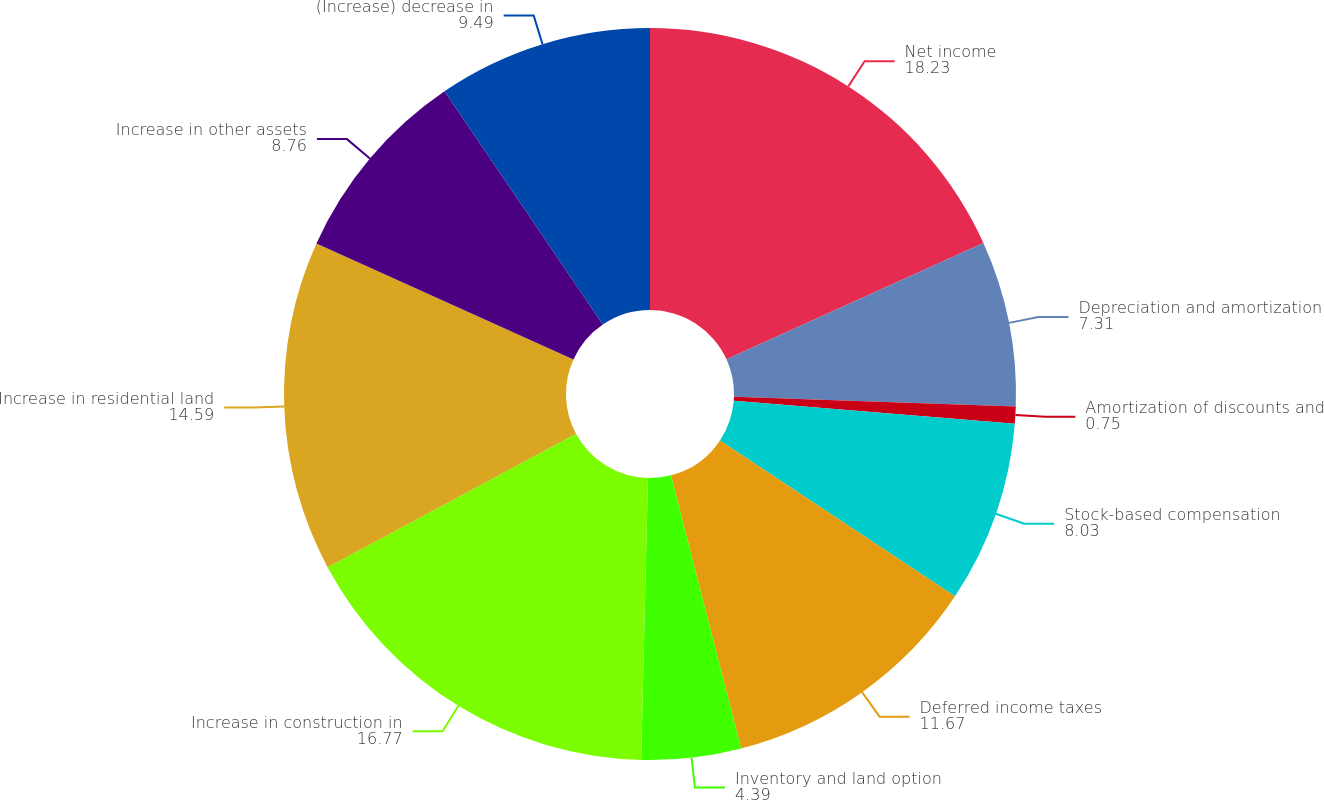<chart> <loc_0><loc_0><loc_500><loc_500><pie_chart><fcel>Net income<fcel>Depreciation and amortization<fcel>Amortization of discounts and<fcel>Stock-based compensation<fcel>Deferred income taxes<fcel>Inventory and land option<fcel>Increase in construction in<fcel>Increase in residential land<fcel>Increase in other assets<fcel>(Increase) decrease in<nl><fcel>18.23%<fcel>7.31%<fcel>0.75%<fcel>8.03%<fcel>11.67%<fcel>4.39%<fcel>16.77%<fcel>14.59%<fcel>8.76%<fcel>9.49%<nl></chart> 